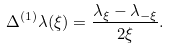Convert formula to latex. <formula><loc_0><loc_0><loc_500><loc_500>\Delta ^ { ( 1 ) } \lambda ( \xi ) = \frac { \lambda _ { \xi } - \lambda _ { - \xi } } { 2 \xi } .</formula> 